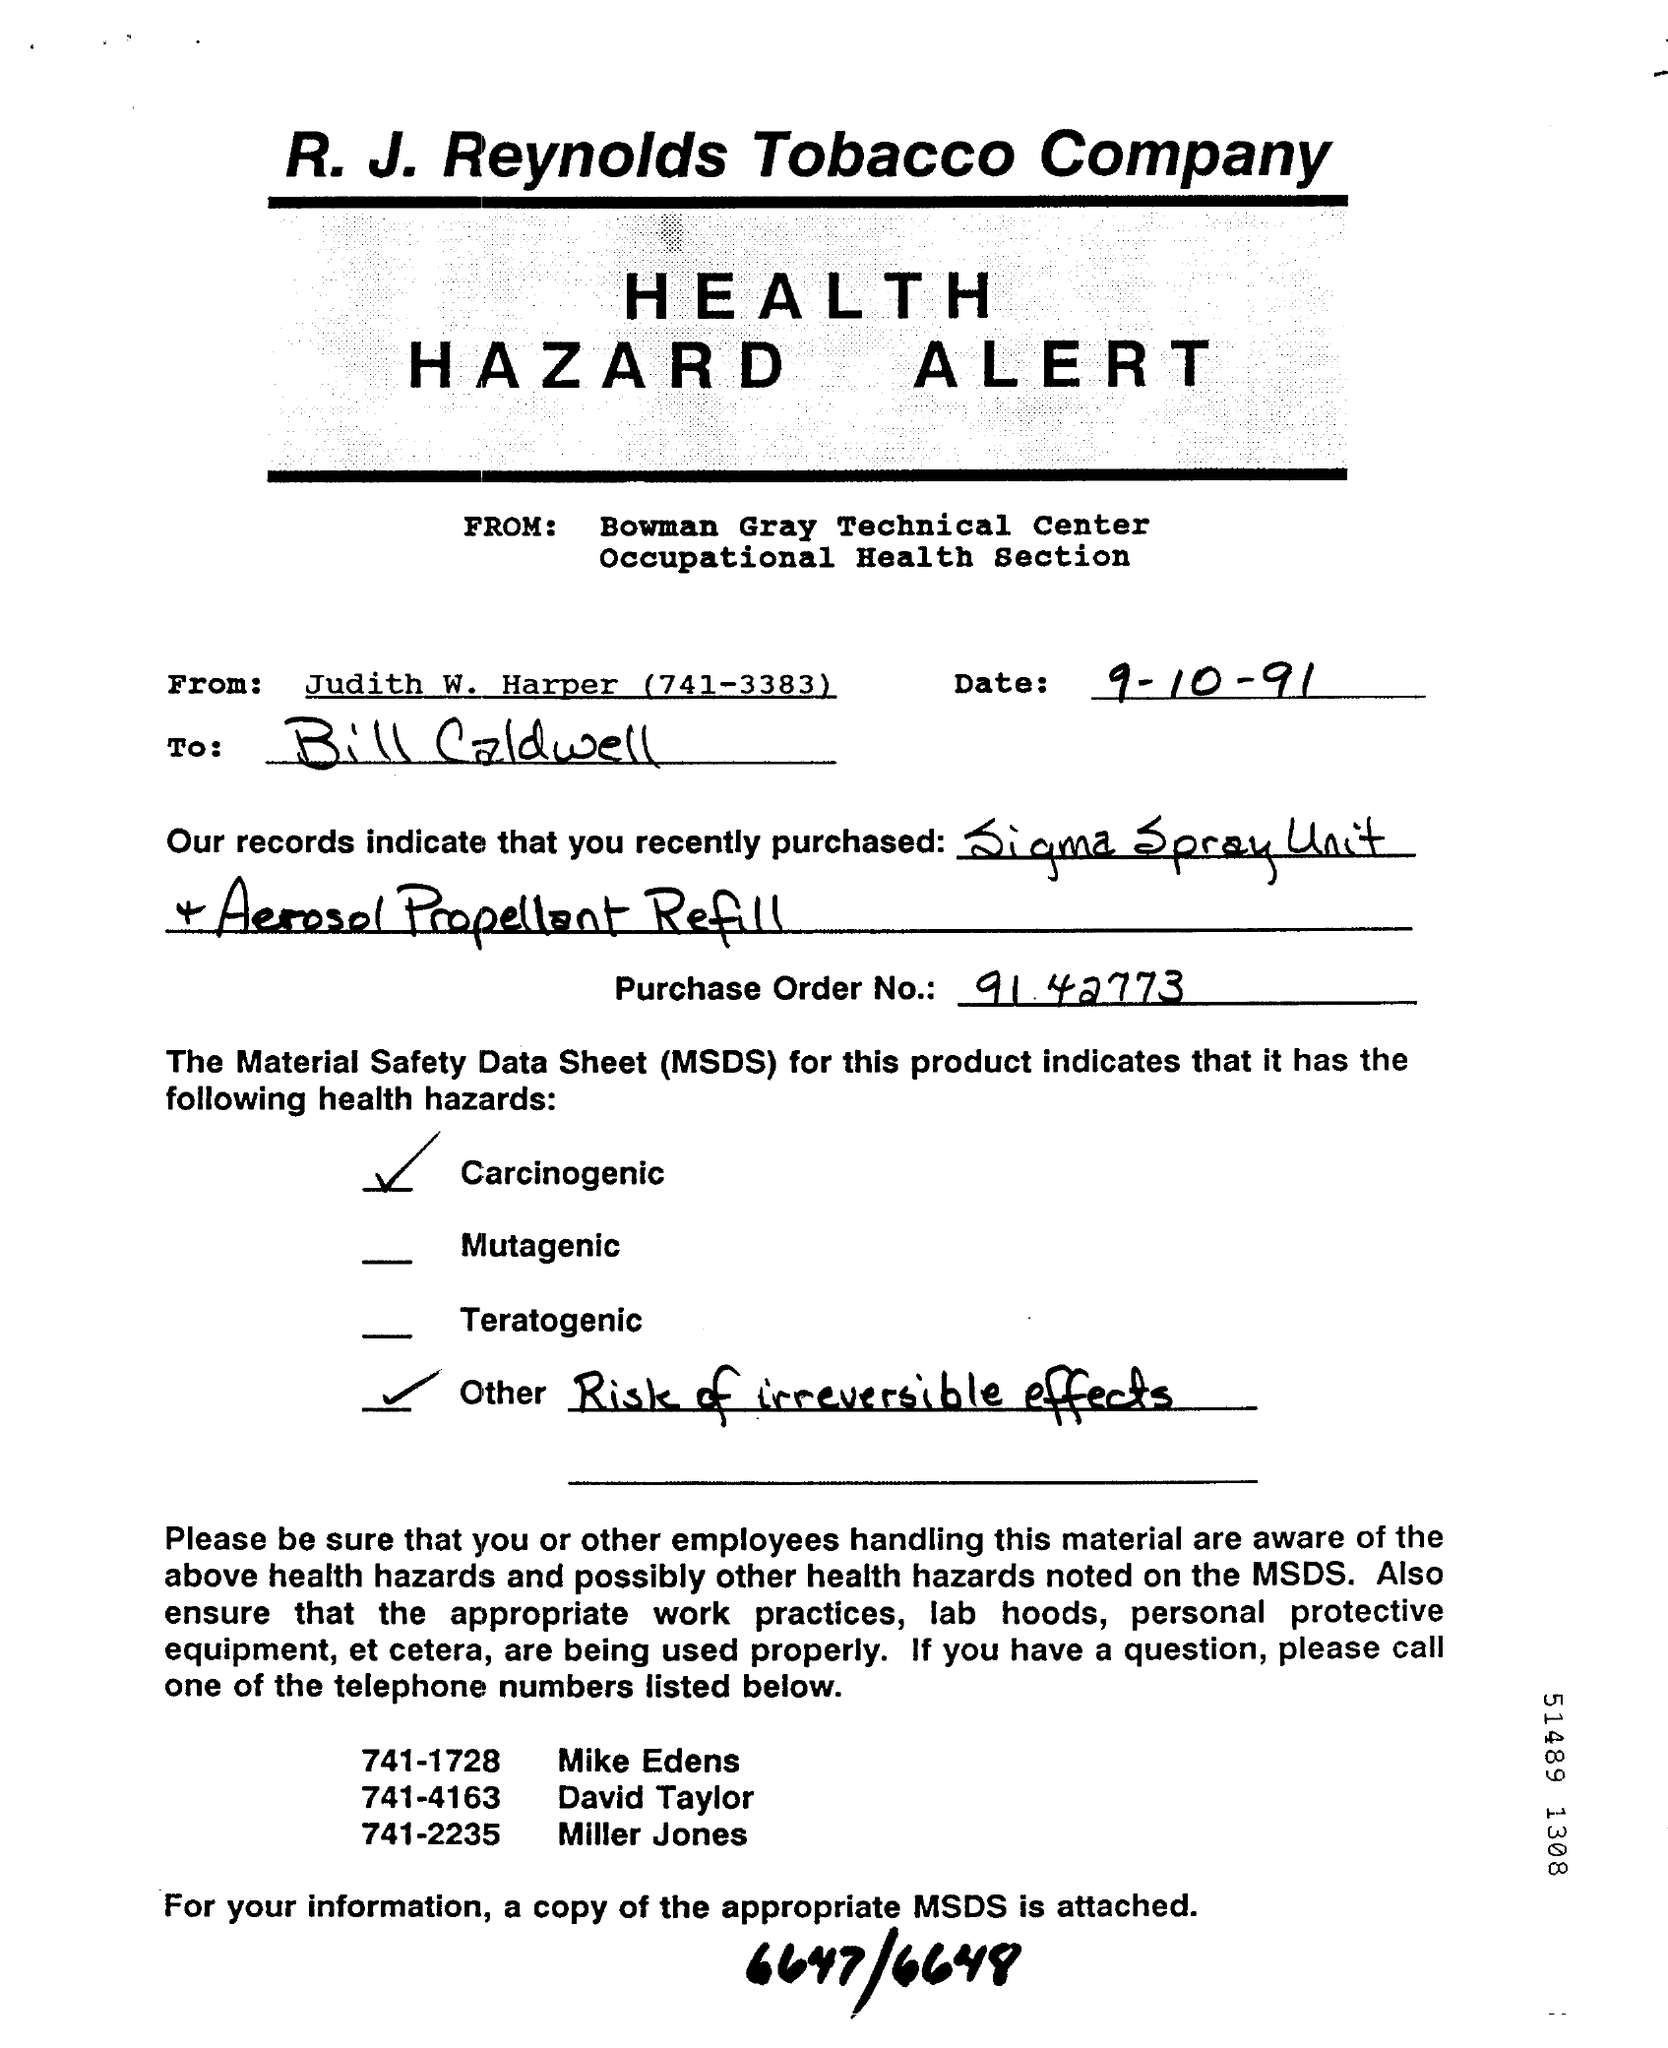What is the date mentioned ?
Offer a very short reply. 9-10-91. From whom this is bill is sent ?
Offer a very short reply. Judith W . Harper. What is the  telephone number of mike edens ?
Ensure brevity in your answer.  741-1728. What is the name of the technical center ?
Your answer should be very brief. Bowman Gray technical center. What is the  telephone number of miller jones ?
Your answer should be compact. 741-2235. What is the  full form of msds
Provide a short and direct response. Material safety data sheet. 